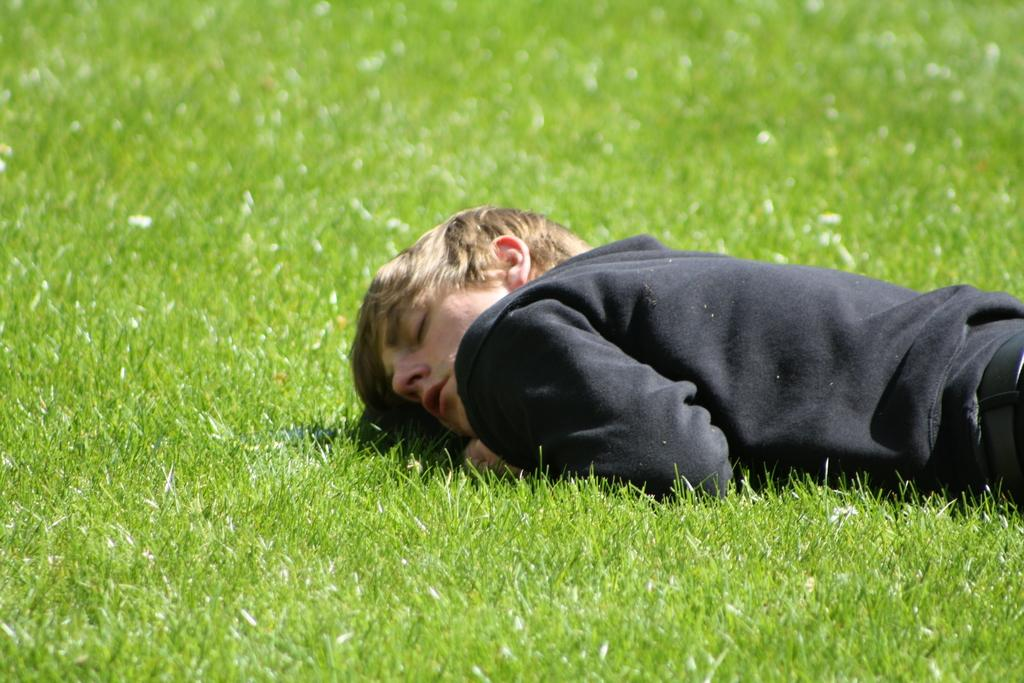What is the main subject of the image? There is a person in the image. What is the person doing in the image? The person is laying on the surface of the grass. What type of stitch is being used to sew the person's clothes in the image? There is no indication of the person's clothes being sewn or any stitch being used in the image. What is the condition of the grass in the image? The provided facts do not mention the condition of the grass, only that the person is laying on the surface of the grass. 